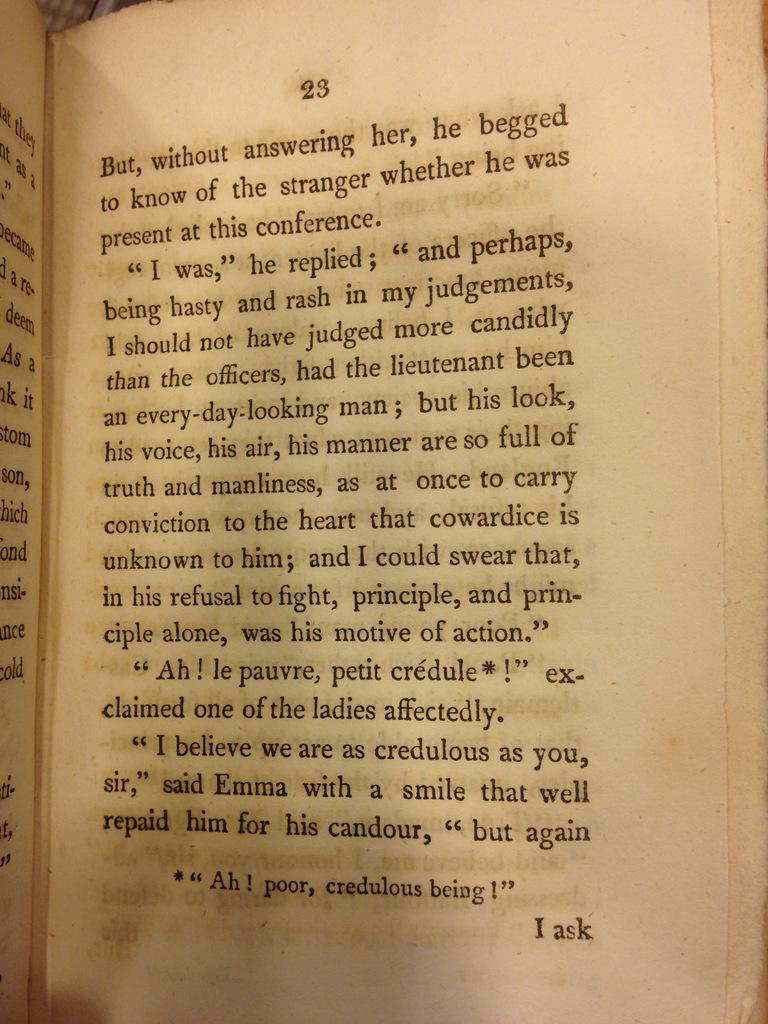What does the only french phrase on the page mean when translated into english?
Make the answer very short. Ah! poor, credulous being!. 